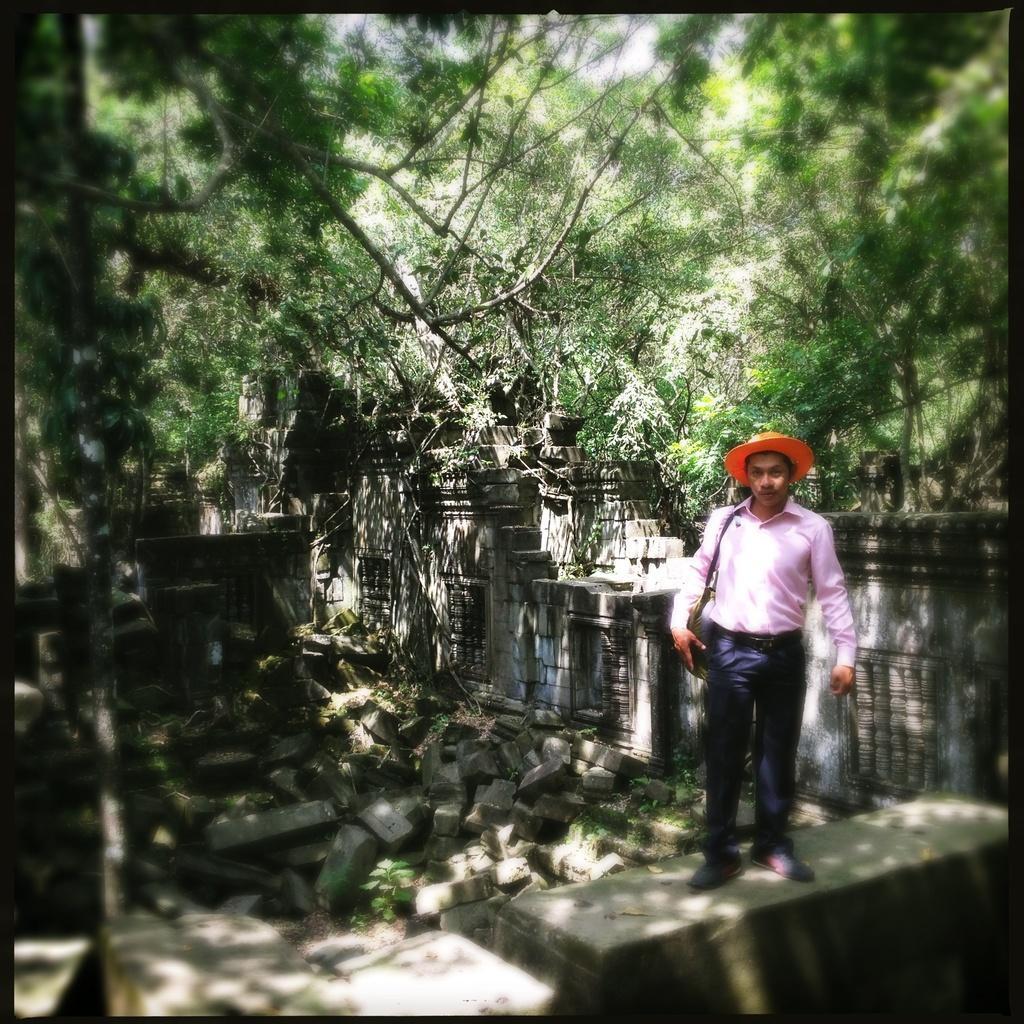How would you summarize this image in a sentence or two? On the right there is a man standing on a platform and he is a carrying a bag on his shoulder and a hat on his head. In the background there are stones,wall and trees. 